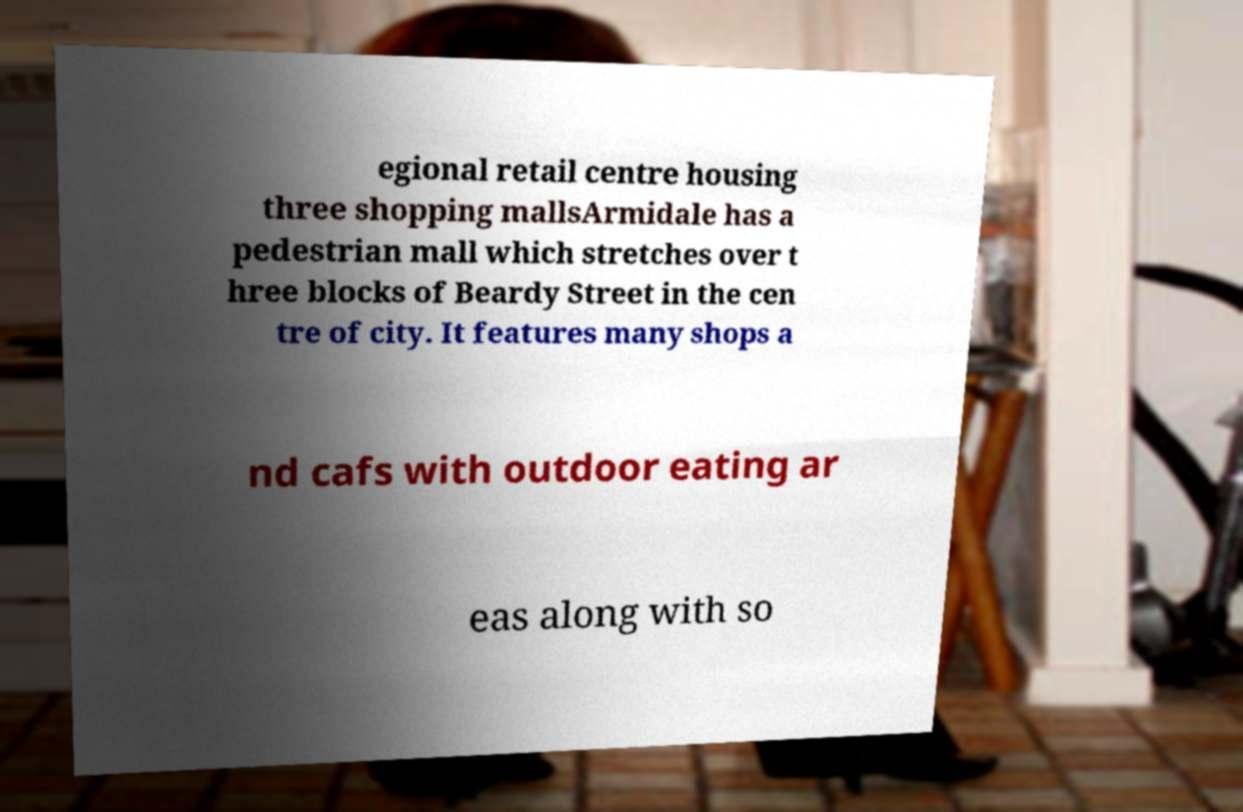Could you extract and type out the text from this image? egional retail centre housing three shopping mallsArmidale has a pedestrian mall which stretches over t hree blocks of Beardy Street in the cen tre of city. It features many shops a nd cafs with outdoor eating ar eas along with so 